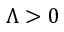Convert formula to latex. <formula><loc_0><loc_0><loc_500><loc_500>\Lambda > 0</formula> 